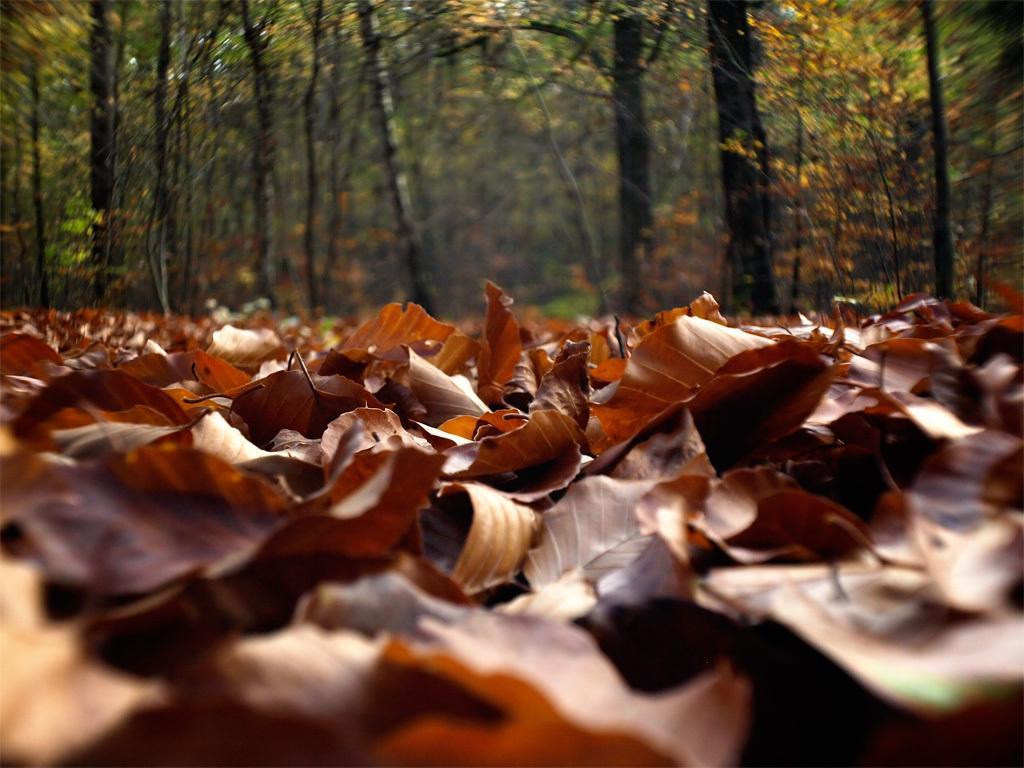Please provide a concise description of this image. In the foreground of the picture there are dry leaves. In the background there are trees. 